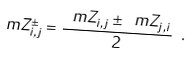<formula> <loc_0><loc_0><loc_500><loc_500>\ m Z ^ { \pm } _ { i , j } = \frac { \ m Z _ { i , j } \pm \ m Z _ { j , i } } { 2 } \ .</formula> 